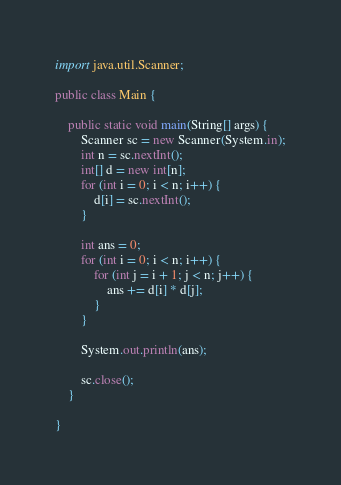Convert code to text. <code><loc_0><loc_0><loc_500><loc_500><_Java_>import java.util.Scanner;

public class Main {

    public static void main(String[] args) {
        Scanner sc = new Scanner(System.in);
        int n = sc.nextInt();
        int[] d = new int[n];
        for (int i = 0; i < n; i++) {
            d[i] = sc.nextInt();
        }

        int ans = 0;
        for (int i = 0; i < n; i++) {
            for (int j = i + 1; j < n; j++) {
                ans += d[i] * d[j];
            }
        }

        System.out.println(ans);

        sc.close();
    }

}
</code> 